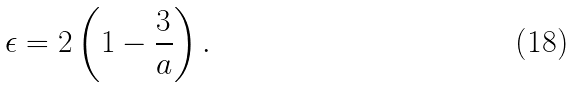Convert formula to latex. <formula><loc_0><loc_0><loc_500><loc_500>\epsilon = 2 \left ( 1 - \frac { 3 } { a } \right ) .</formula> 